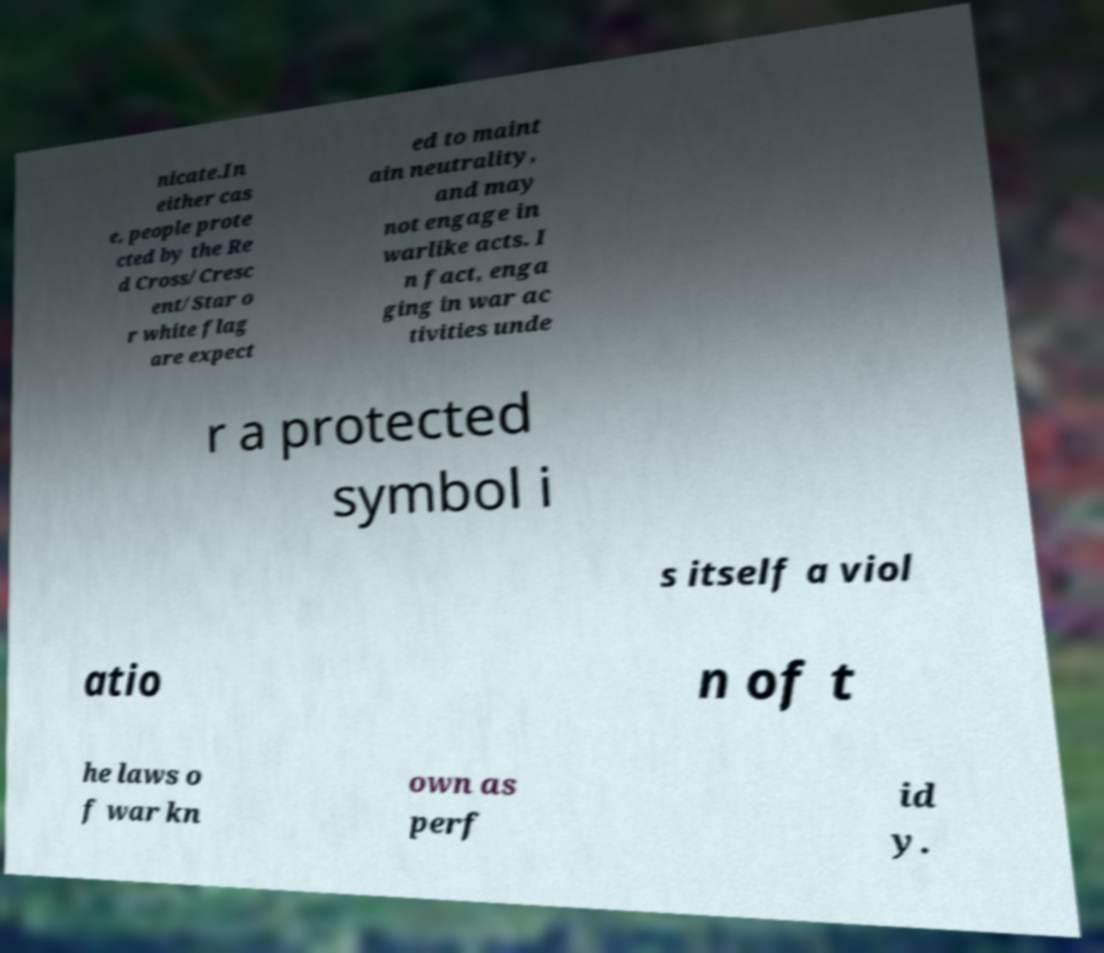Can you accurately transcribe the text from the provided image for me? nicate.In either cas e, people prote cted by the Re d Cross/Cresc ent/Star o r white flag are expect ed to maint ain neutrality, and may not engage in warlike acts. I n fact, enga ging in war ac tivities unde r a protected symbol i s itself a viol atio n of t he laws o f war kn own as perf id y. 